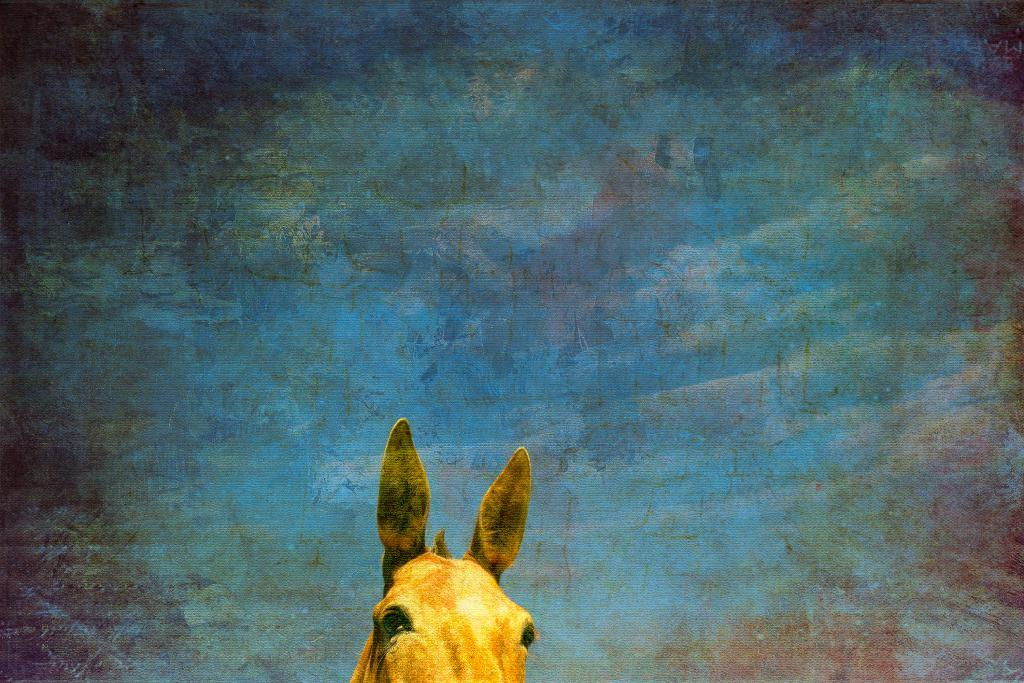What is the main subject of the image? The main subject of the image is a horse's head. Where is the horse's head located in the image? The horse's head is at the bottom of the image. What type of cloth is draped over the horse's head in the image? There is no cloth draped over the horse's head in the image; it only shows the horse's head without any additional items. 